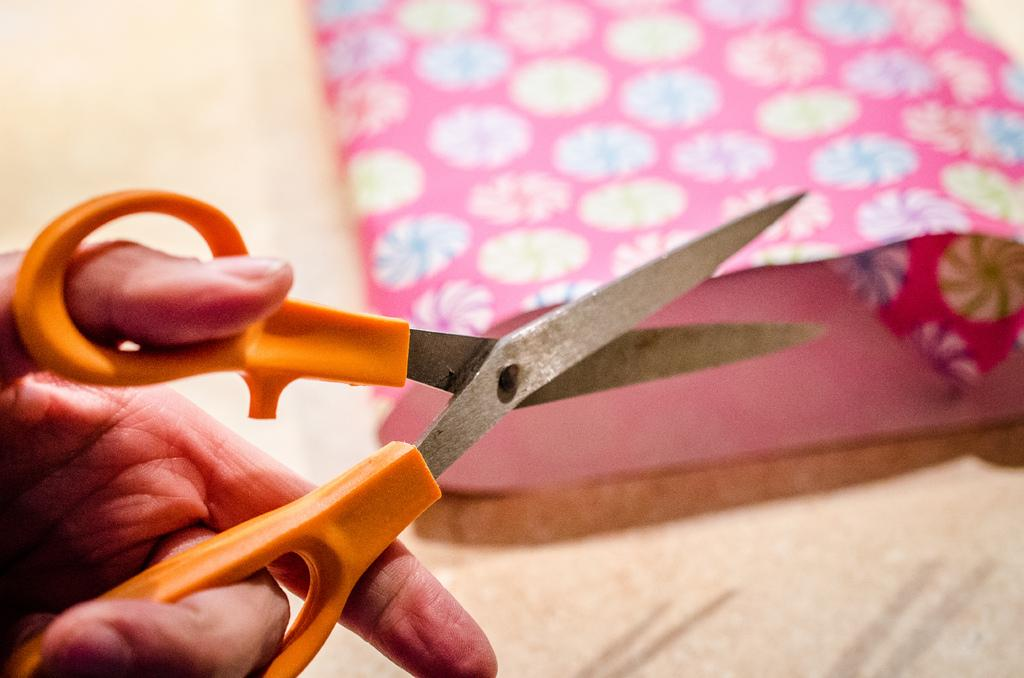What object can be seen in the image that is used for cutting? There are scissors in the image that are used for cutting. What is the color of the scissors? The scissors are orange in color. Whose hand is holding the scissors in the image? A person's hand is holding the scissors in the image. What type of surface is visible in the image? There is a cream-colored surface in the image. What is placed on the surface? There is a pink-colored paper on the surface. What type of scarecrow is standing in the background of the image? There is no scarecrow present in the image. What attraction can be seen in the distance in the image? There is no attraction visible in the image. 